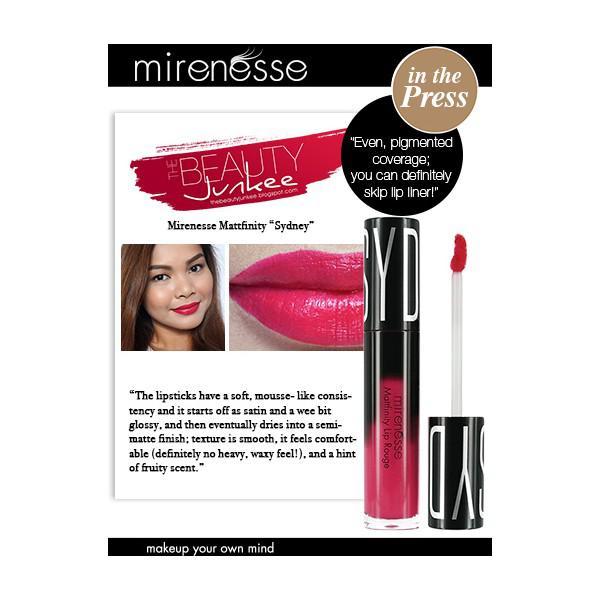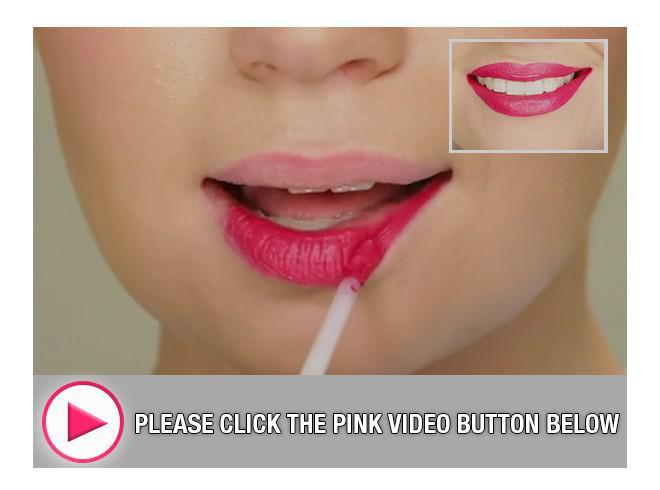The first image is the image on the left, the second image is the image on the right. Evaluate the accuracy of this statement regarding the images: "One image shows lipstick on skin that is not lips.". Is it true? Answer yes or no. No. The first image is the image on the left, the second image is the image on the right. Given the left and right images, does the statement "Right image shows a model's face on black next to a lipstick brush and tube." hold true? Answer yes or no. No. 